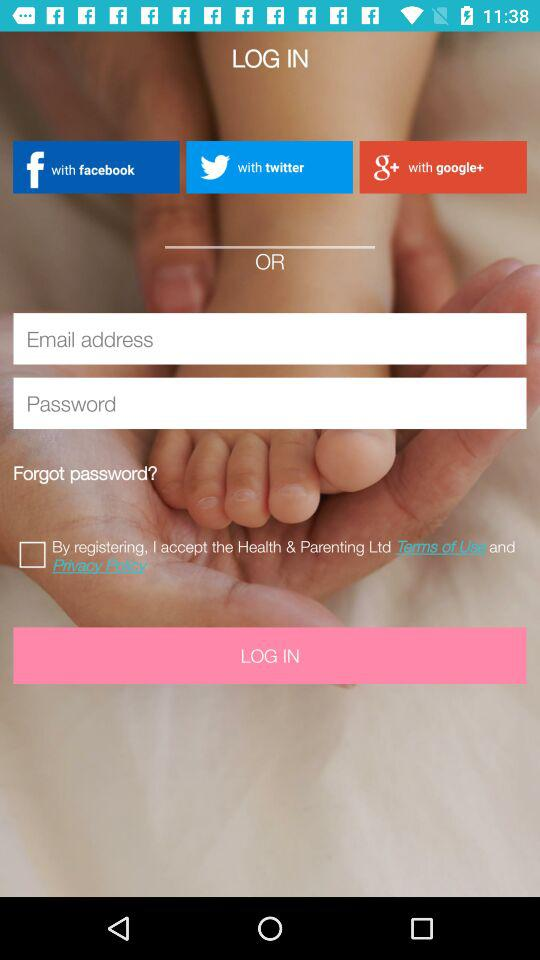What accounts can I use to sign up? You can sign up with your "facebook", "twitter" and "google+" accounts. 